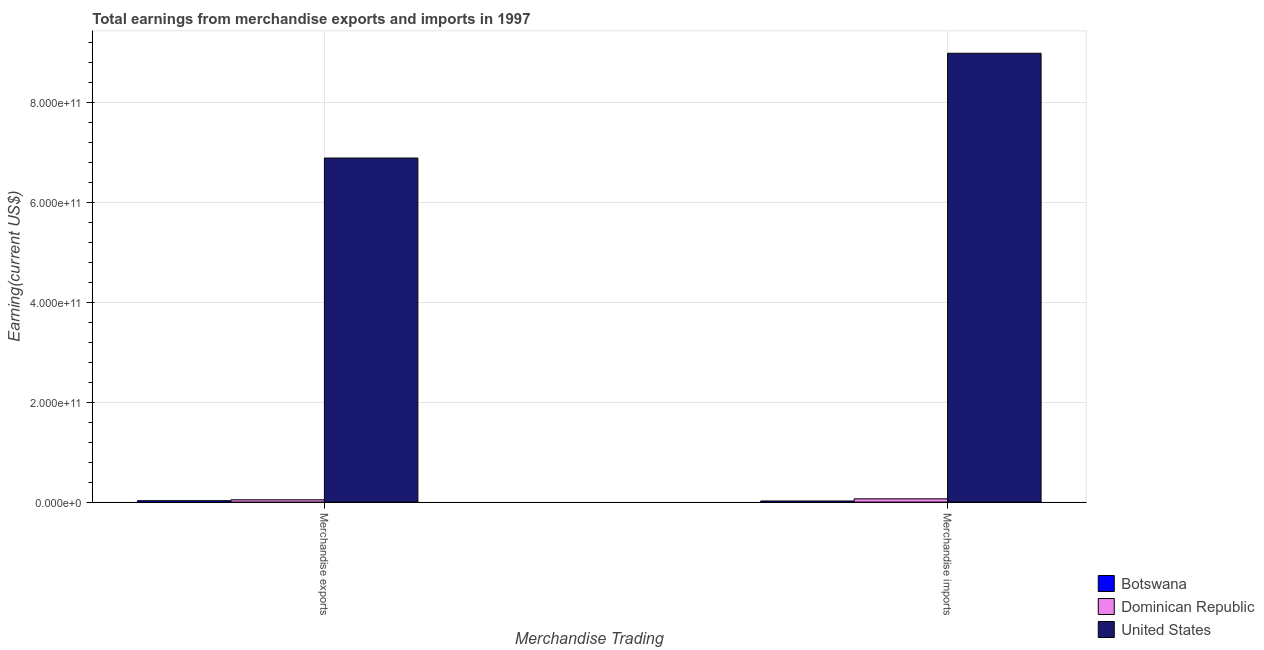How many different coloured bars are there?
Ensure brevity in your answer.  3. How many groups of bars are there?
Give a very brief answer. 2. Are the number of bars per tick equal to the number of legend labels?
Make the answer very short. Yes. Are the number of bars on each tick of the X-axis equal?
Your answer should be very brief. Yes. How many bars are there on the 1st tick from the left?
Offer a very short reply. 3. What is the earnings from merchandise exports in Dominican Republic?
Your response must be concise. 4.61e+09. Across all countries, what is the maximum earnings from merchandise exports?
Keep it short and to the point. 6.89e+11. Across all countries, what is the minimum earnings from merchandise imports?
Offer a very short reply. 2.26e+09. In which country was the earnings from merchandise exports maximum?
Offer a very short reply. United States. In which country was the earnings from merchandise exports minimum?
Make the answer very short. Botswana. What is the total earnings from merchandise imports in the graph?
Provide a succinct answer. 9.08e+11. What is the difference between the earnings from merchandise exports in Botswana and that in Dominican Republic?
Give a very brief answer. -1.77e+09. What is the difference between the earnings from merchandise imports in United States and the earnings from merchandise exports in Dominican Republic?
Keep it short and to the point. 8.94e+11. What is the average earnings from merchandise imports per country?
Your answer should be compact. 3.03e+11. What is the difference between the earnings from merchandise imports and earnings from merchandise exports in Botswana?
Your answer should be very brief. -5.84e+08. What is the ratio of the earnings from merchandise imports in Dominican Republic to that in United States?
Make the answer very short. 0.01. Is the earnings from merchandise imports in Dominican Republic less than that in United States?
Your answer should be compact. Yes. What does the 1st bar from the right in Merchandise exports represents?
Your answer should be compact. United States. How many bars are there?
Provide a short and direct response. 6. How many countries are there in the graph?
Give a very brief answer. 3. What is the difference between two consecutive major ticks on the Y-axis?
Your answer should be very brief. 2.00e+11. Does the graph contain grids?
Offer a very short reply. Yes. How many legend labels are there?
Offer a very short reply. 3. What is the title of the graph?
Offer a very short reply. Total earnings from merchandise exports and imports in 1997. What is the label or title of the X-axis?
Your answer should be very brief. Merchandise Trading. What is the label or title of the Y-axis?
Make the answer very short. Earning(current US$). What is the Earning(current US$) of Botswana in Merchandise exports?
Your answer should be compact. 2.84e+09. What is the Earning(current US$) in Dominican Republic in Merchandise exports?
Your answer should be compact. 4.61e+09. What is the Earning(current US$) of United States in Merchandise exports?
Offer a terse response. 6.89e+11. What is the Earning(current US$) in Botswana in Merchandise imports?
Make the answer very short. 2.26e+09. What is the Earning(current US$) in Dominican Republic in Merchandise imports?
Ensure brevity in your answer.  6.61e+09. What is the Earning(current US$) in United States in Merchandise imports?
Provide a short and direct response. 8.99e+11. Across all Merchandise Trading, what is the maximum Earning(current US$) of Botswana?
Your answer should be compact. 2.84e+09. Across all Merchandise Trading, what is the maximum Earning(current US$) of Dominican Republic?
Give a very brief answer. 6.61e+09. Across all Merchandise Trading, what is the maximum Earning(current US$) in United States?
Make the answer very short. 8.99e+11. Across all Merchandise Trading, what is the minimum Earning(current US$) of Botswana?
Give a very brief answer. 2.26e+09. Across all Merchandise Trading, what is the minimum Earning(current US$) in Dominican Republic?
Your answer should be very brief. 4.61e+09. Across all Merchandise Trading, what is the minimum Earning(current US$) of United States?
Make the answer very short. 6.89e+11. What is the total Earning(current US$) in Botswana in the graph?
Provide a short and direct response. 5.10e+09. What is the total Earning(current US$) in Dominican Republic in the graph?
Your answer should be very brief. 1.12e+1. What is the total Earning(current US$) in United States in the graph?
Ensure brevity in your answer.  1.59e+12. What is the difference between the Earning(current US$) in Botswana in Merchandise exports and that in Merchandise imports?
Provide a short and direct response. 5.84e+08. What is the difference between the Earning(current US$) of Dominican Republic in Merchandise exports and that in Merchandise imports?
Offer a terse response. -2.00e+09. What is the difference between the Earning(current US$) of United States in Merchandise exports and that in Merchandise imports?
Your answer should be compact. -2.10e+11. What is the difference between the Earning(current US$) of Botswana in Merchandise exports and the Earning(current US$) of Dominican Republic in Merchandise imports?
Your answer should be very brief. -3.77e+09. What is the difference between the Earning(current US$) in Botswana in Merchandise exports and the Earning(current US$) in United States in Merchandise imports?
Keep it short and to the point. -8.96e+11. What is the difference between the Earning(current US$) of Dominican Republic in Merchandise exports and the Earning(current US$) of United States in Merchandise imports?
Your response must be concise. -8.94e+11. What is the average Earning(current US$) in Botswana per Merchandise Trading?
Provide a succinct answer. 2.55e+09. What is the average Earning(current US$) in Dominican Republic per Merchandise Trading?
Keep it short and to the point. 5.61e+09. What is the average Earning(current US$) in United States per Merchandise Trading?
Provide a succinct answer. 7.94e+11. What is the difference between the Earning(current US$) in Botswana and Earning(current US$) in Dominican Republic in Merchandise exports?
Provide a short and direct response. -1.77e+09. What is the difference between the Earning(current US$) in Botswana and Earning(current US$) in United States in Merchandise exports?
Provide a succinct answer. -6.86e+11. What is the difference between the Earning(current US$) in Dominican Republic and Earning(current US$) in United States in Merchandise exports?
Your answer should be compact. -6.85e+11. What is the difference between the Earning(current US$) of Botswana and Earning(current US$) of Dominican Republic in Merchandise imports?
Provide a succinct answer. -4.35e+09. What is the difference between the Earning(current US$) in Botswana and Earning(current US$) in United States in Merchandise imports?
Your answer should be compact. -8.97e+11. What is the difference between the Earning(current US$) of Dominican Republic and Earning(current US$) of United States in Merchandise imports?
Give a very brief answer. -8.92e+11. What is the ratio of the Earning(current US$) of Botswana in Merchandise exports to that in Merchandise imports?
Your response must be concise. 1.26. What is the ratio of the Earning(current US$) in Dominican Republic in Merchandise exports to that in Merchandise imports?
Ensure brevity in your answer.  0.7. What is the ratio of the Earning(current US$) of United States in Merchandise exports to that in Merchandise imports?
Your answer should be very brief. 0.77. What is the difference between the highest and the second highest Earning(current US$) in Botswana?
Ensure brevity in your answer.  5.84e+08. What is the difference between the highest and the second highest Earning(current US$) of Dominican Republic?
Your response must be concise. 2.00e+09. What is the difference between the highest and the second highest Earning(current US$) in United States?
Offer a terse response. 2.10e+11. What is the difference between the highest and the lowest Earning(current US$) in Botswana?
Your answer should be compact. 5.84e+08. What is the difference between the highest and the lowest Earning(current US$) of Dominican Republic?
Provide a short and direct response. 2.00e+09. What is the difference between the highest and the lowest Earning(current US$) of United States?
Give a very brief answer. 2.10e+11. 